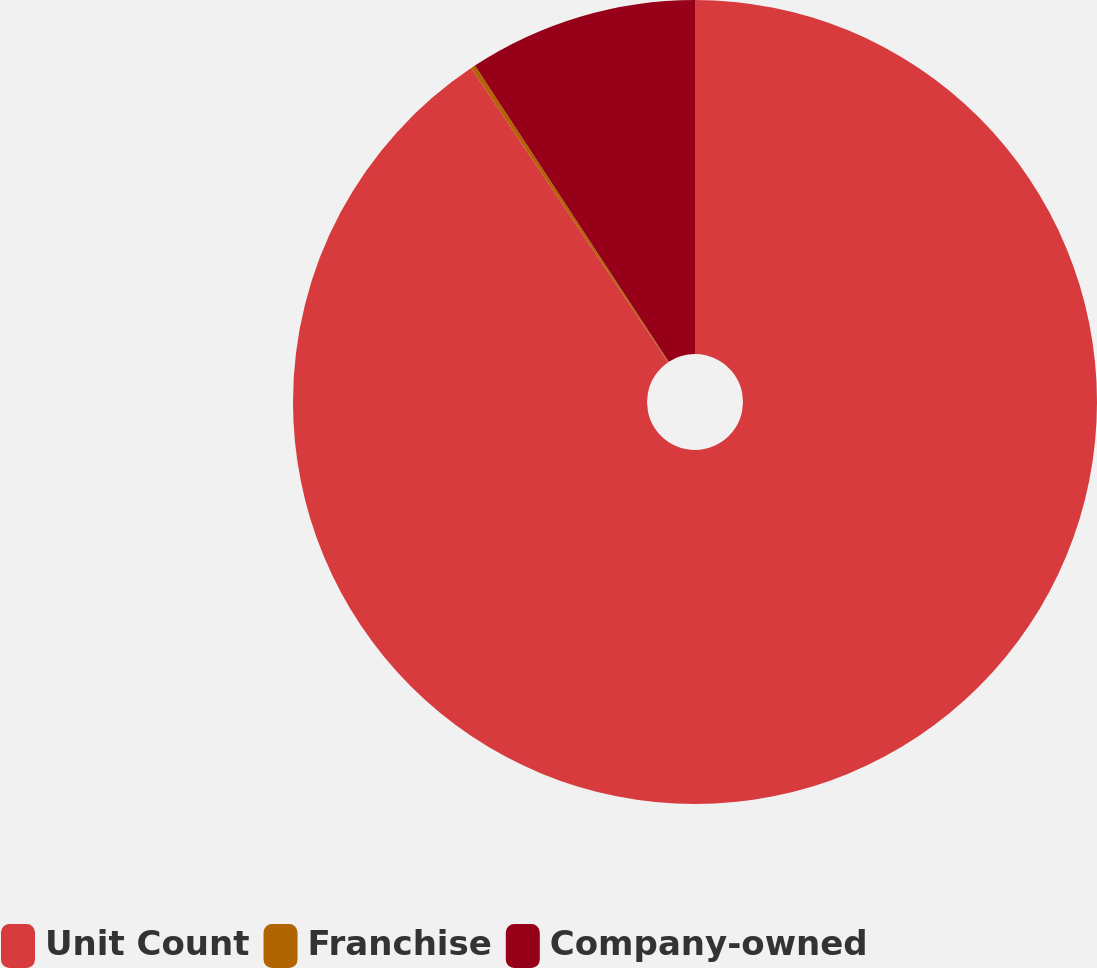Convert chart to OTSL. <chart><loc_0><loc_0><loc_500><loc_500><pie_chart><fcel>Unit Count<fcel>Franchise<fcel>Company-owned<nl><fcel>90.6%<fcel>0.18%<fcel>9.22%<nl></chart> 